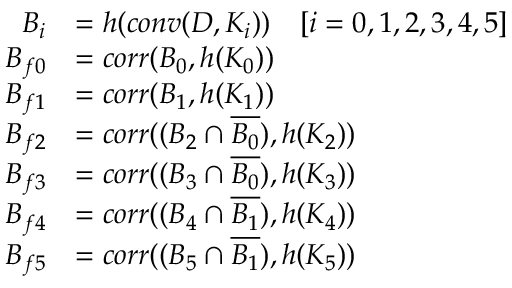Convert formula to latex. <formula><loc_0><loc_0><loc_500><loc_500>\begin{array} { r l } { B _ { i } } & { = h ( c o n v ( D , K _ { i } ) ) \quad [ i = 0 , 1 , 2 , 3 , 4 , 5 ] } \\ { B _ { f 0 } } & { = c o r r ( B _ { 0 } , h ( K _ { 0 } ) ) } \\ { B _ { f 1 } } & { = c o r r ( B _ { 1 } , h ( K _ { 1 } ) ) } \\ { B _ { f 2 } } & { = c o r r ( ( B _ { 2 } \cap \overline { { B _ { 0 } } } ) , h ( K _ { 2 } ) ) } \\ { B _ { f 3 } } & { = c o r r ( ( B _ { 3 } \cap \overline { { B _ { 0 } } } ) , h ( K _ { 3 } ) ) } \\ { B _ { f 4 } } & { = c o r r ( ( B _ { 4 } \cap \overline { { B _ { 1 } } } ) , h ( K _ { 4 } ) ) } \\ { B _ { f 5 } } & { = c o r r ( ( B _ { 5 } \cap \overline { { B _ { 1 } } } ) , h ( K _ { 5 } ) ) } \end{array}</formula> 